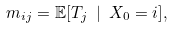<formula> <loc_0><loc_0><loc_500><loc_500>m _ { i j } = \mathbb { E } [ T _ { j } \ | \ X _ { 0 } = i ] ,</formula> 